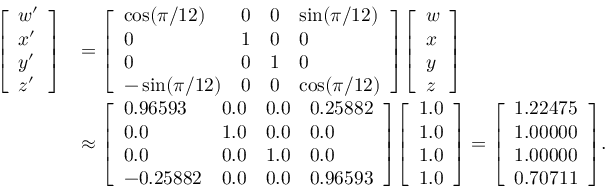<formula> <loc_0><loc_0><loc_500><loc_500>{ \begin{array} { r l } { { \left [ \begin{array} { l } { w ^ { \prime } } \\ { x ^ { \prime } } \\ { y ^ { \prime } } \\ { z ^ { \prime } } \end{array} \right ] } } & { = { \left [ \begin{array} { l l l l } { \cos ( \pi / 1 2 ) } & { 0 } & { 0 } & { \sin ( \pi / 1 2 ) } \\ { 0 } & { 1 } & { 0 } & { 0 } \\ { 0 } & { 0 } & { 1 } & { 0 } \\ { - \sin ( \pi / 1 2 ) } & { 0 } & { 0 } & { \cos ( \pi / 1 2 ) } \end{array} \right ] } { \left [ \begin{array} { l } { w } \\ { x } \\ { y } \\ { z } \end{array} \right ] } } \\ & { \approx { \left [ \begin{array} { l l l l } { 0 . 9 6 5 9 3 } & { 0 . 0 } & { 0 . 0 } & { 0 . 2 5 8 8 2 } \\ { 0 . 0 } & { 1 . 0 } & { 0 . 0 } & { 0 . 0 } \\ { 0 . 0 } & { 0 . 0 } & { 1 . 0 } & { 0 . 0 } \\ { - 0 . 2 5 8 8 2 } & { 0 . 0 } & { 0 . 0 } & { 0 . 9 6 5 9 3 } \end{array} \right ] } { \left [ \begin{array} { l } { 1 . 0 } \\ { 1 . 0 } \\ { 1 . 0 } \\ { 1 . 0 } \end{array} \right ] } = { \left [ \begin{array} { l } { 1 . 2 2 4 7 5 } \\ { 1 . 0 0 0 0 0 } \\ { 1 . 0 0 0 0 0 } \\ { 0 . 7 0 7 1 1 } \end{array} \right ] } . } \end{array} }</formula> 